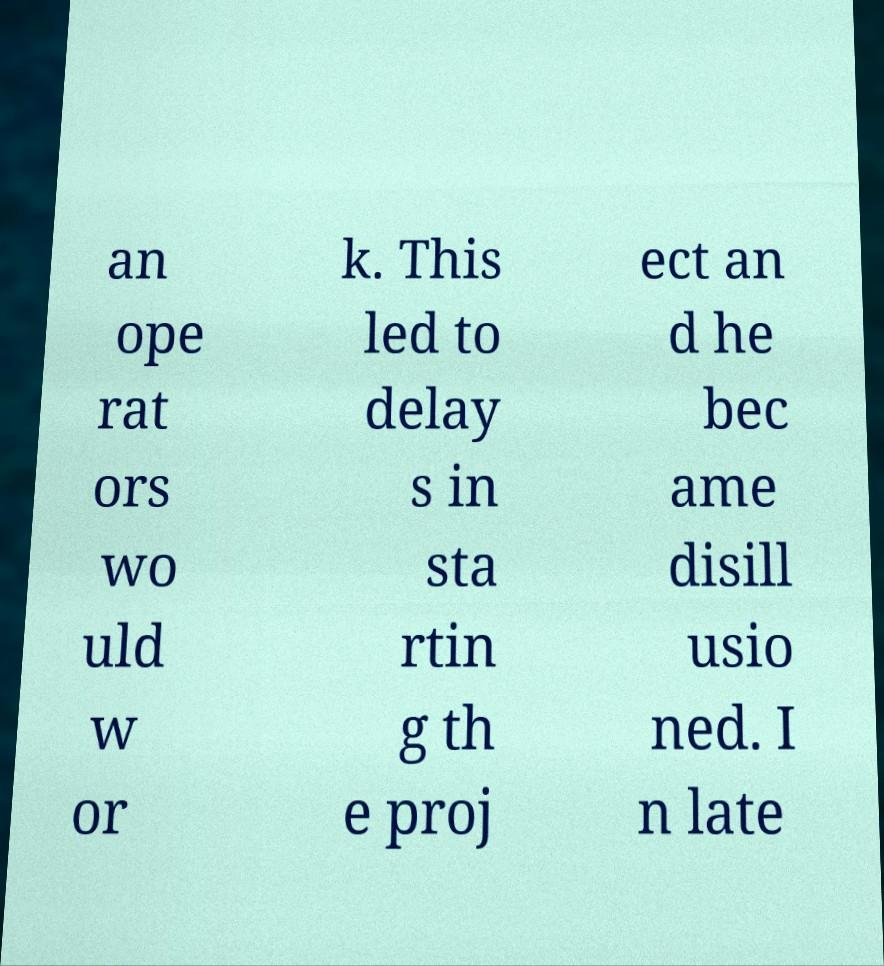Can you accurately transcribe the text from the provided image for me? an ope rat ors wo uld w or k. This led to delay s in sta rtin g th e proj ect an d he bec ame disill usio ned. I n late 